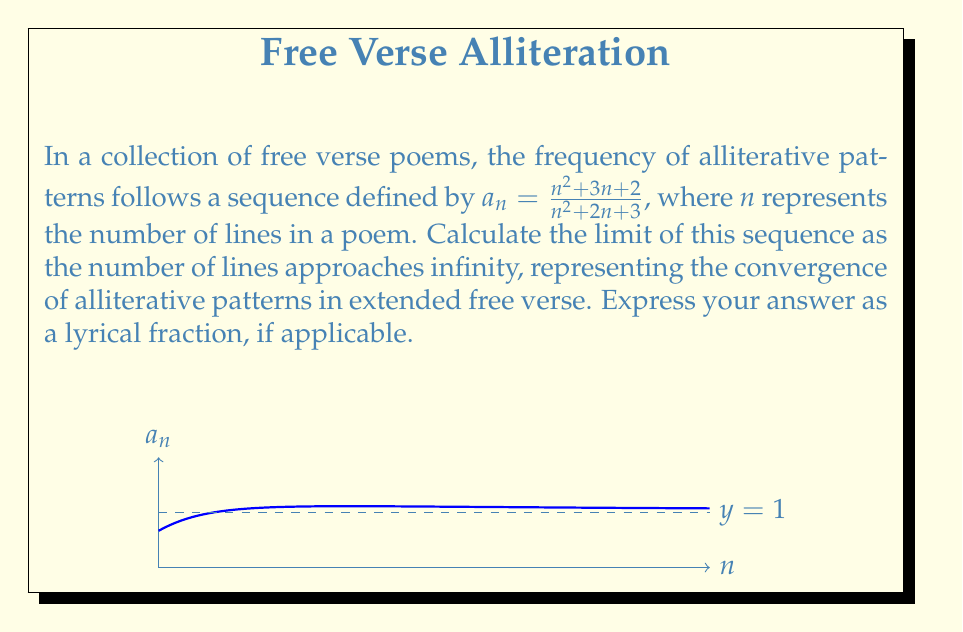Can you answer this question? To find the limit of the sequence as $n$ approaches infinity, we'll follow these poetic steps:

1) First, let's consider the general term of the sequence:

   $$a_n = \frac{n^2 + 3n + 2}{n^2 + 2n + 3}$$

2) To find the limit as $n$ approaches infinity, we'll divide both the numerator and denominator by the highest power of $n$, which is $n^2$:

   $$\lim_{n \to \infty} a_n = \lim_{n \to \infty} \frac{n^2 + 3n + 2}{n^2 + 2n + 3} = \lim_{n \to \infty} \frac{\frac{n^2}{n^2} + \frac{3n}{n^2} + \frac{2}{n^2}}{\frac{n^2}{n^2} + \frac{2n}{n^2} + \frac{3}{n^2}}$$

3) Simplify:

   $$\lim_{n \to \infty} \frac{1 + \frac{3}{n} + \frac{2}{n^2}}{1 + \frac{2}{n} + \frac{3}{n^2}}$$

4) As $n$ approaches infinity, $\frac{1}{n}$ and $\frac{1}{n^2}$ approach 0:

   $$\lim_{n \to \infty} \frac{1 + 0 + 0}{1 + 0 + 0} = \frac{1}{1} = 1$$

Thus, the alliterative patterns in free verse converge to a perfect unity, a singularity of sound and rhythm.
Answer: 1 